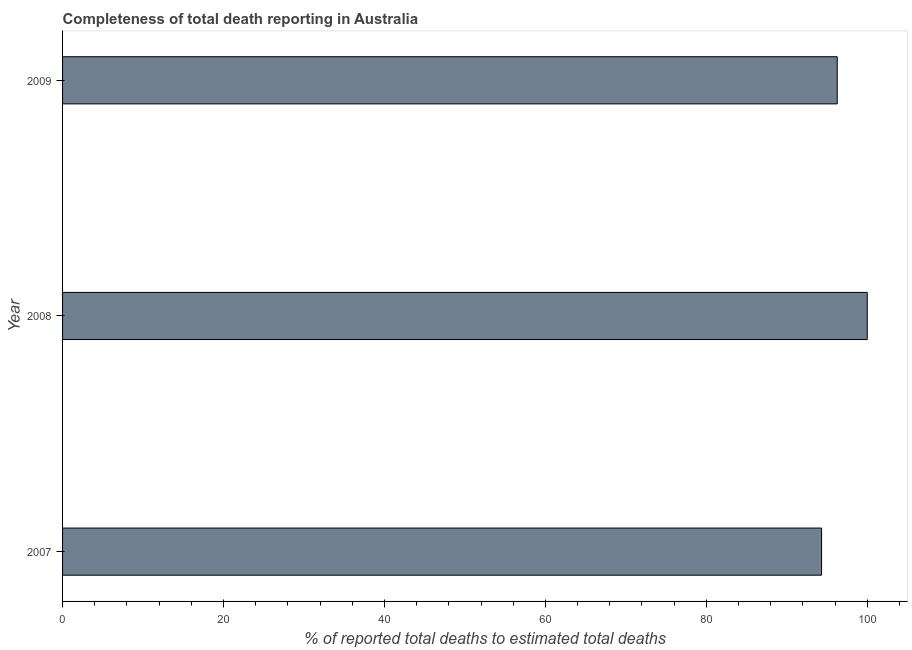Does the graph contain any zero values?
Your answer should be very brief. No. What is the title of the graph?
Provide a short and direct response. Completeness of total death reporting in Australia. What is the label or title of the X-axis?
Offer a very short reply. % of reported total deaths to estimated total deaths. What is the completeness of total death reports in 2009?
Provide a short and direct response. 96.27. Across all years, what is the minimum completeness of total death reports?
Give a very brief answer. 94.32. In which year was the completeness of total death reports minimum?
Offer a very short reply. 2007. What is the sum of the completeness of total death reports?
Your answer should be compact. 290.59. What is the difference between the completeness of total death reports in 2007 and 2009?
Your answer should be very brief. -1.94. What is the average completeness of total death reports per year?
Make the answer very short. 96.86. What is the median completeness of total death reports?
Keep it short and to the point. 96.27. In how many years, is the completeness of total death reports greater than 28 %?
Offer a very short reply. 3. Do a majority of the years between 2008 and 2007 (inclusive) have completeness of total death reports greater than 84 %?
Ensure brevity in your answer.  No. What is the ratio of the completeness of total death reports in 2007 to that in 2009?
Your answer should be very brief. 0.98. Is the difference between the completeness of total death reports in 2008 and 2009 greater than the difference between any two years?
Provide a short and direct response. No. What is the difference between the highest and the second highest completeness of total death reports?
Your response must be concise. 3.73. What is the difference between the highest and the lowest completeness of total death reports?
Provide a short and direct response. 5.68. Are all the bars in the graph horizontal?
Provide a succinct answer. Yes. What is the difference between two consecutive major ticks on the X-axis?
Provide a succinct answer. 20. Are the values on the major ticks of X-axis written in scientific E-notation?
Your answer should be very brief. No. What is the % of reported total deaths to estimated total deaths in 2007?
Offer a very short reply. 94.32. What is the % of reported total deaths to estimated total deaths in 2009?
Offer a very short reply. 96.27. What is the difference between the % of reported total deaths to estimated total deaths in 2007 and 2008?
Keep it short and to the point. -5.68. What is the difference between the % of reported total deaths to estimated total deaths in 2007 and 2009?
Your answer should be compact. -1.94. What is the difference between the % of reported total deaths to estimated total deaths in 2008 and 2009?
Provide a short and direct response. 3.73. What is the ratio of the % of reported total deaths to estimated total deaths in 2007 to that in 2008?
Offer a terse response. 0.94. What is the ratio of the % of reported total deaths to estimated total deaths in 2007 to that in 2009?
Keep it short and to the point. 0.98. What is the ratio of the % of reported total deaths to estimated total deaths in 2008 to that in 2009?
Your response must be concise. 1.04. 